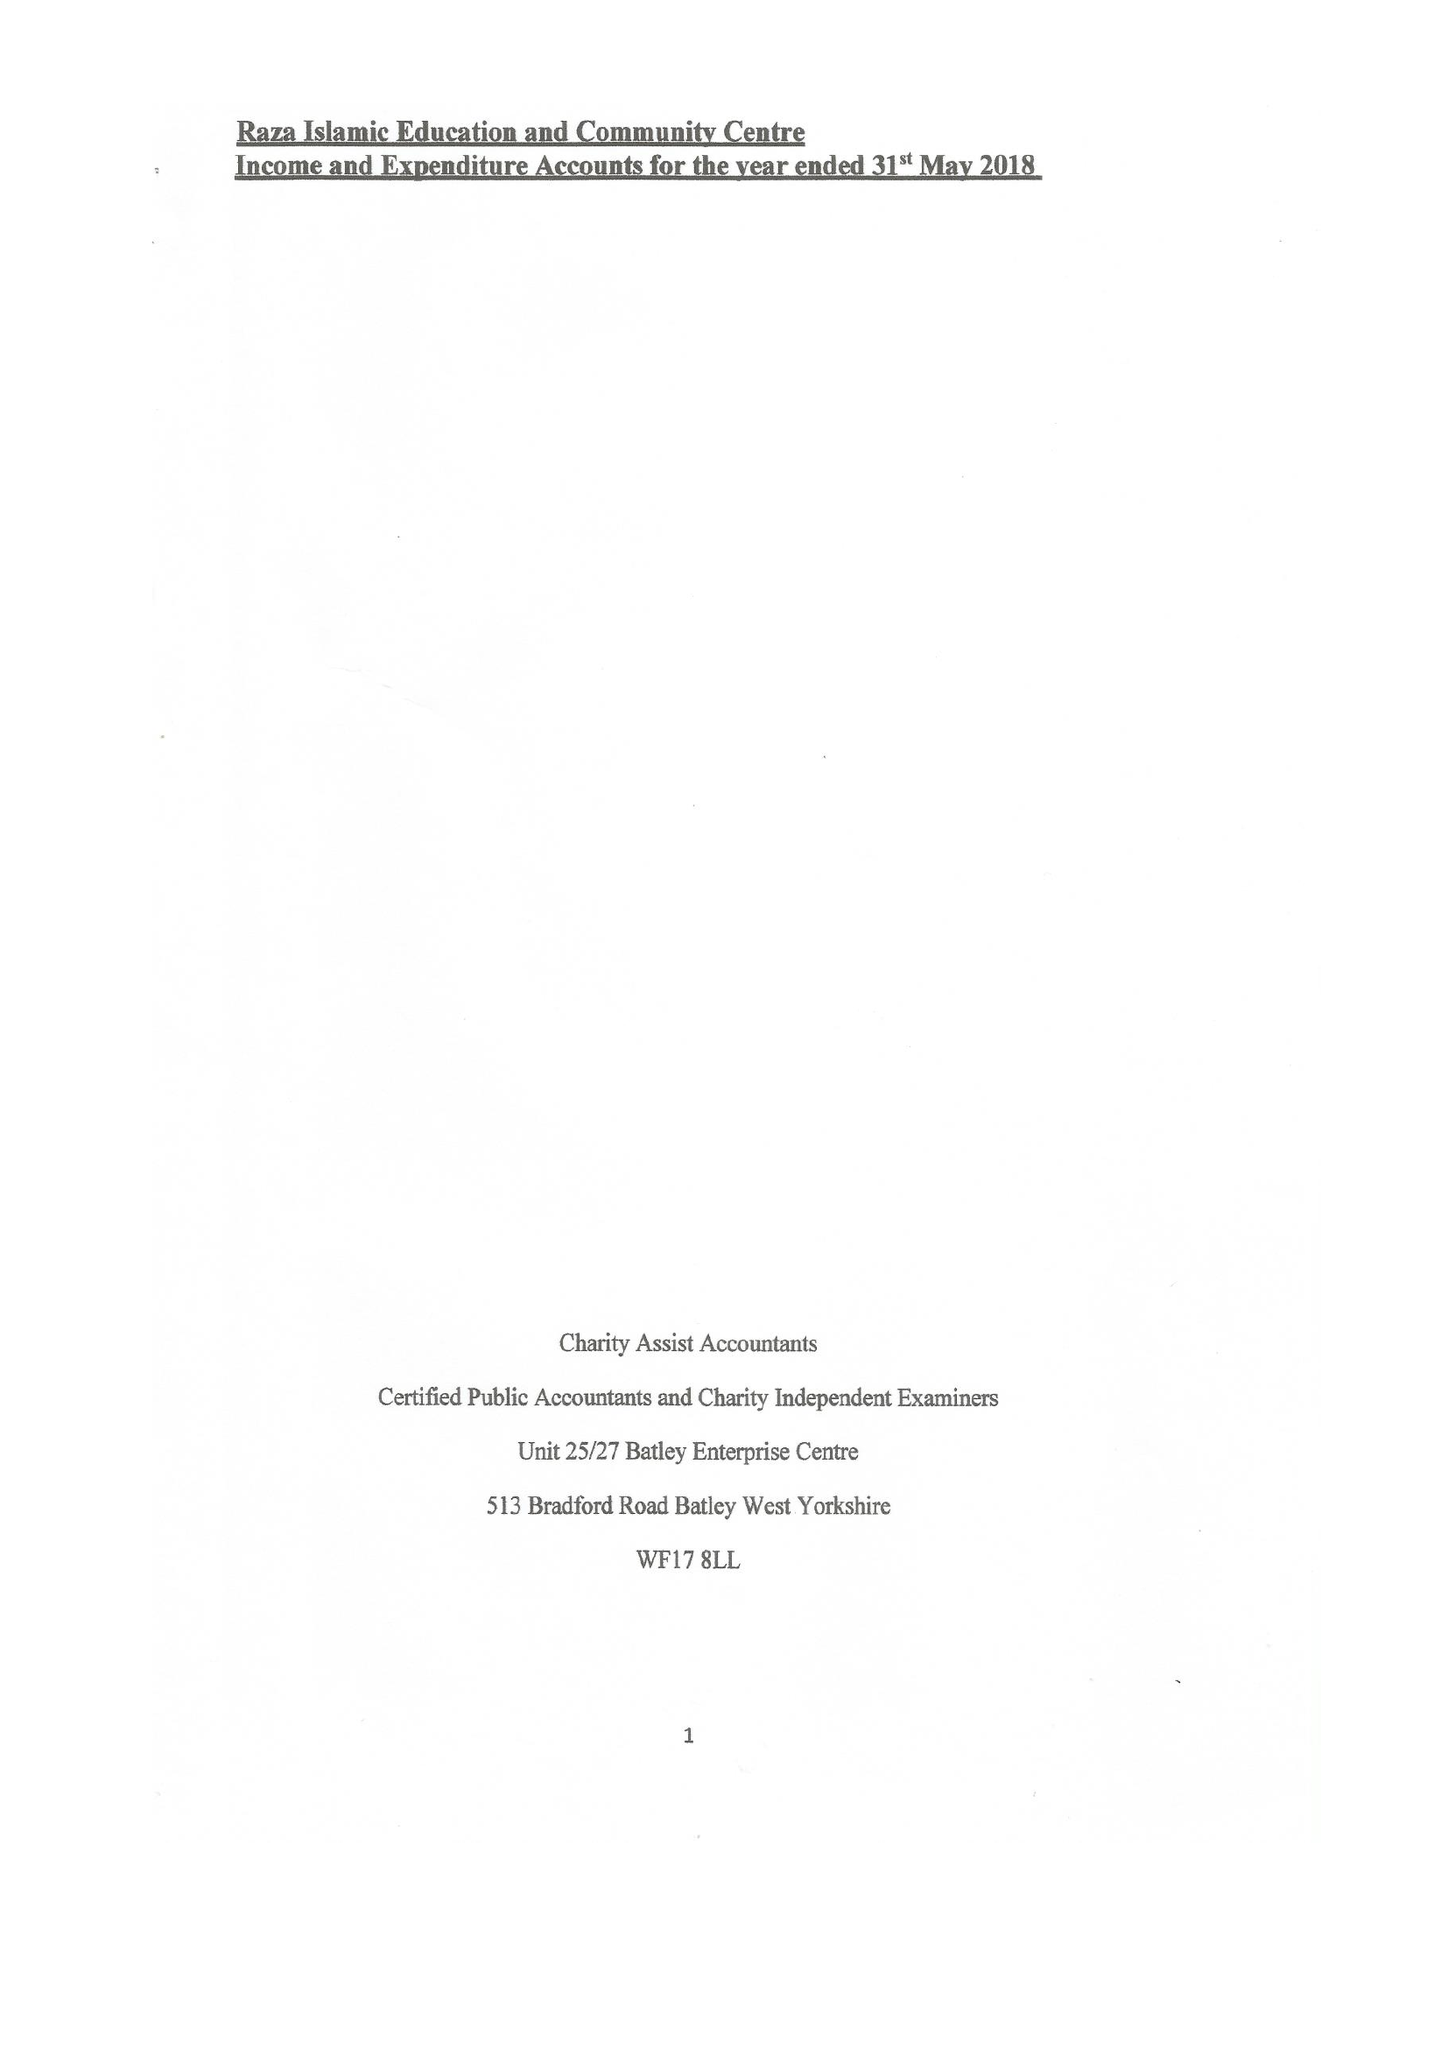What is the value for the address__postcode?
Answer the question using a single word or phrase. WF12 9HB 